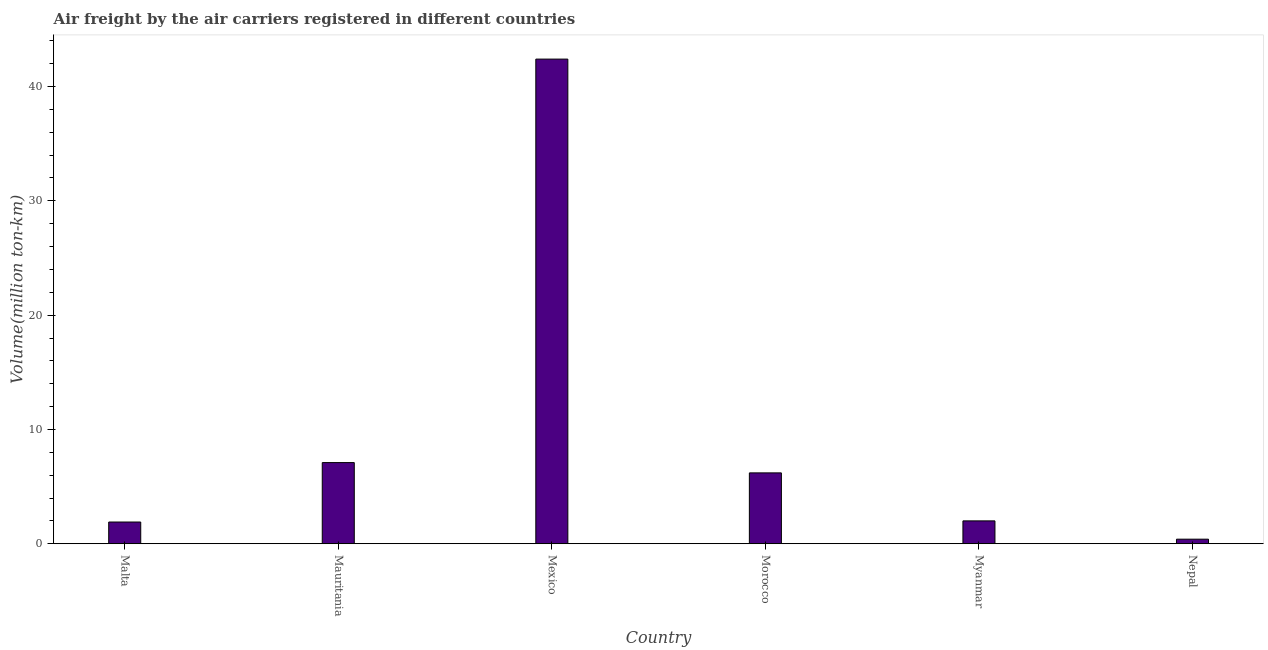Does the graph contain grids?
Keep it short and to the point. No. What is the title of the graph?
Your answer should be compact. Air freight by the air carriers registered in different countries. What is the label or title of the X-axis?
Keep it short and to the point. Country. What is the label or title of the Y-axis?
Keep it short and to the point. Volume(million ton-km). What is the air freight in Malta?
Provide a short and direct response. 1.9. Across all countries, what is the maximum air freight?
Your response must be concise. 42.4. Across all countries, what is the minimum air freight?
Make the answer very short. 0.4. In which country was the air freight minimum?
Give a very brief answer. Nepal. What is the sum of the air freight?
Make the answer very short. 60. What is the difference between the air freight in Malta and Nepal?
Your response must be concise. 1.5. What is the average air freight per country?
Your answer should be very brief. 10. What is the median air freight?
Make the answer very short. 4.1. In how many countries, is the air freight greater than 34 million ton-km?
Keep it short and to the point. 1. What is the ratio of the air freight in Mexico to that in Nepal?
Ensure brevity in your answer.  106. What is the difference between the highest and the second highest air freight?
Ensure brevity in your answer.  35.3. Is the sum of the air freight in Mexico and Nepal greater than the maximum air freight across all countries?
Give a very brief answer. Yes. In how many countries, is the air freight greater than the average air freight taken over all countries?
Offer a terse response. 1. How many countries are there in the graph?
Your response must be concise. 6. Are the values on the major ticks of Y-axis written in scientific E-notation?
Ensure brevity in your answer.  No. What is the Volume(million ton-km) of Malta?
Your answer should be compact. 1.9. What is the Volume(million ton-km) in Mauritania?
Your answer should be very brief. 7.1. What is the Volume(million ton-km) in Mexico?
Your answer should be very brief. 42.4. What is the Volume(million ton-km) in Morocco?
Give a very brief answer. 6.2. What is the Volume(million ton-km) of Myanmar?
Ensure brevity in your answer.  2. What is the Volume(million ton-km) in Nepal?
Your response must be concise. 0.4. What is the difference between the Volume(million ton-km) in Malta and Mexico?
Make the answer very short. -40.5. What is the difference between the Volume(million ton-km) in Malta and Myanmar?
Keep it short and to the point. -0.1. What is the difference between the Volume(million ton-km) in Mauritania and Mexico?
Give a very brief answer. -35.3. What is the difference between the Volume(million ton-km) in Mauritania and Myanmar?
Your answer should be very brief. 5.1. What is the difference between the Volume(million ton-km) in Mexico and Morocco?
Your answer should be compact. 36.2. What is the difference between the Volume(million ton-km) in Mexico and Myanmar?
Provide a succinct answer. 40.4. What is the difference between the Volume(million ton-km) in Myanmar and Nepal?
Provide a short and direct response. 1.6. What is the ratio of the Volume(million ton-km) in Malta to that in Mauritania?
Your answer should be compact. 0.27. What is the ratio of the Volume(million ton-km) in Malta to that in Mexico?
Offer a very short reply. 0.04. What is the ratio of the Volume(million ton-km) in Malta to that in Morocco?
Offer a very short reply. 0.31. What is the ratio of the Volume(million ton-km) in Malta to that in Myanmar?
Keep it short and to the point. 0.95. What is the ratio of the Volume(million ton-km) in Malta to that in Nepal?
Offer a terse response. 4.75. What is the ratio of the Volume(million ton-km) in Mauritania to that in Mexico?
Give a very brief answer. 0.17. What is the ratio of the Volume(million ton-km) in Mauritania to that in Morocco?
Your answer should be compact. 1.15. What is the ratio of the Volume(million ton-km) in Mauritania to that in Myanmar?
Your answer should be very brief. 3.55. What is the ratio of the Volume(million ton-km) in Mauritania to that in Nepal?
Your response must be concise. 17.75. What is the ratio of the Volume(million ton-km) in Mexico to that in Morocco?
Offer a very short reply. 6.84. What is the ratio of the Volume(million ton-km) in Mexico to that in Myanmar?
Your answer should be compact. 21.2. What is the ratio of the Volume(million ton-km) in Mexico to that in Nepal?
Your response must be concise. 106. What is the ratio of the Volume(million ton-km) in Morocco to that in Myanmar?
Offer a terse response. 3.1. What is the ratio of the Volume(million ton-km) in Morocco to that in Nepal?
Provide a short and direct response. 15.5. What is the ratio of the Volume(million ton-km) in Myanmar to that in Nepal?
Provide a short and direct response. 5. 